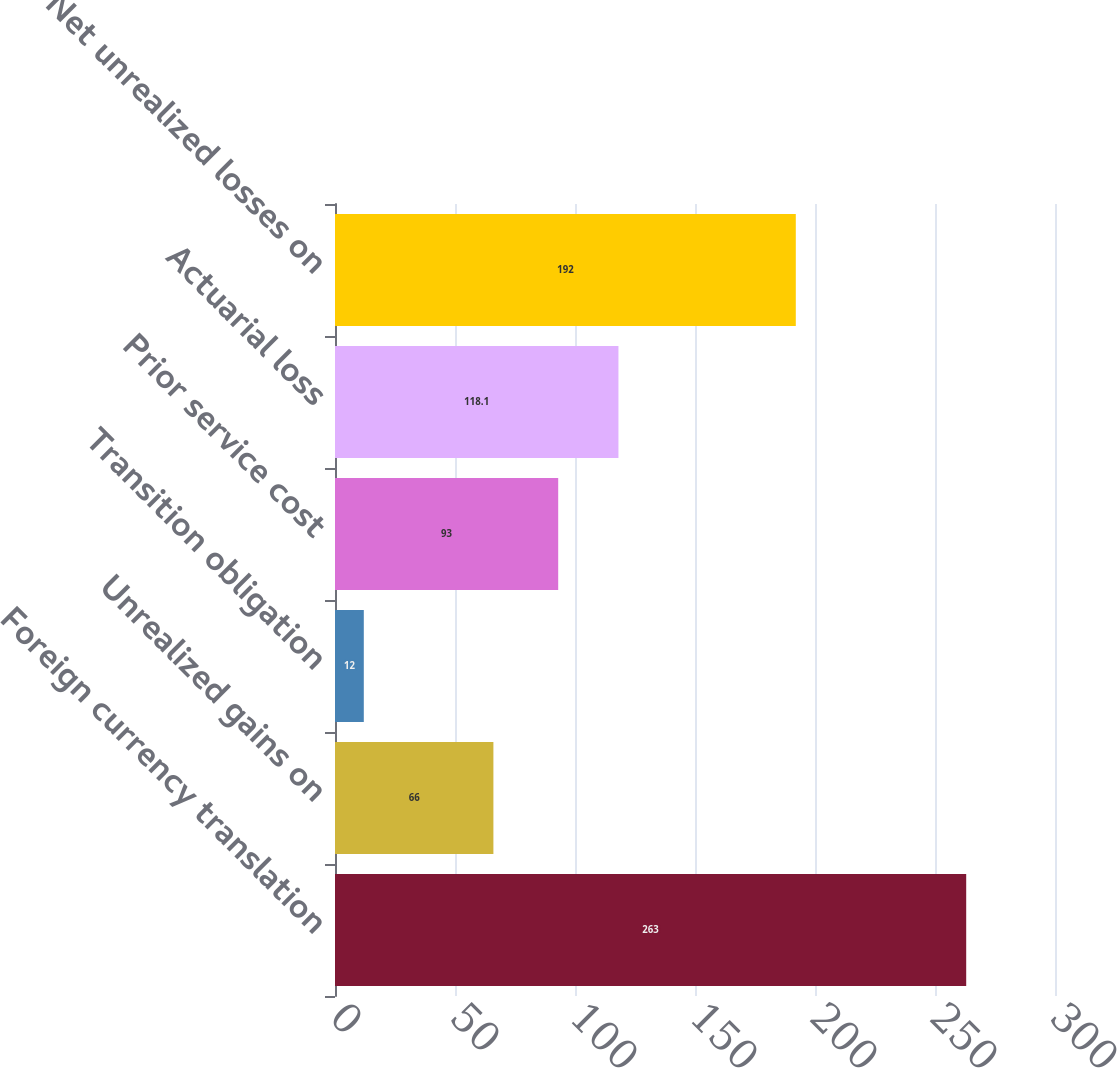Convert chart to OTSL. <chart><loc_0><loc_0><loc_500><loc_500><bar_chart><fcel>Foreign currency translation<fcel>Unrealized gains on<fcel>Transition obligation<fcel>Prior service cost<fcel>Actuarial loss<fcel>Net unrealized losses on<nl><fcel>263<fcel>66<fcel>12<fcel>93<fcel>118.1<fcel>192<nl></chart> 